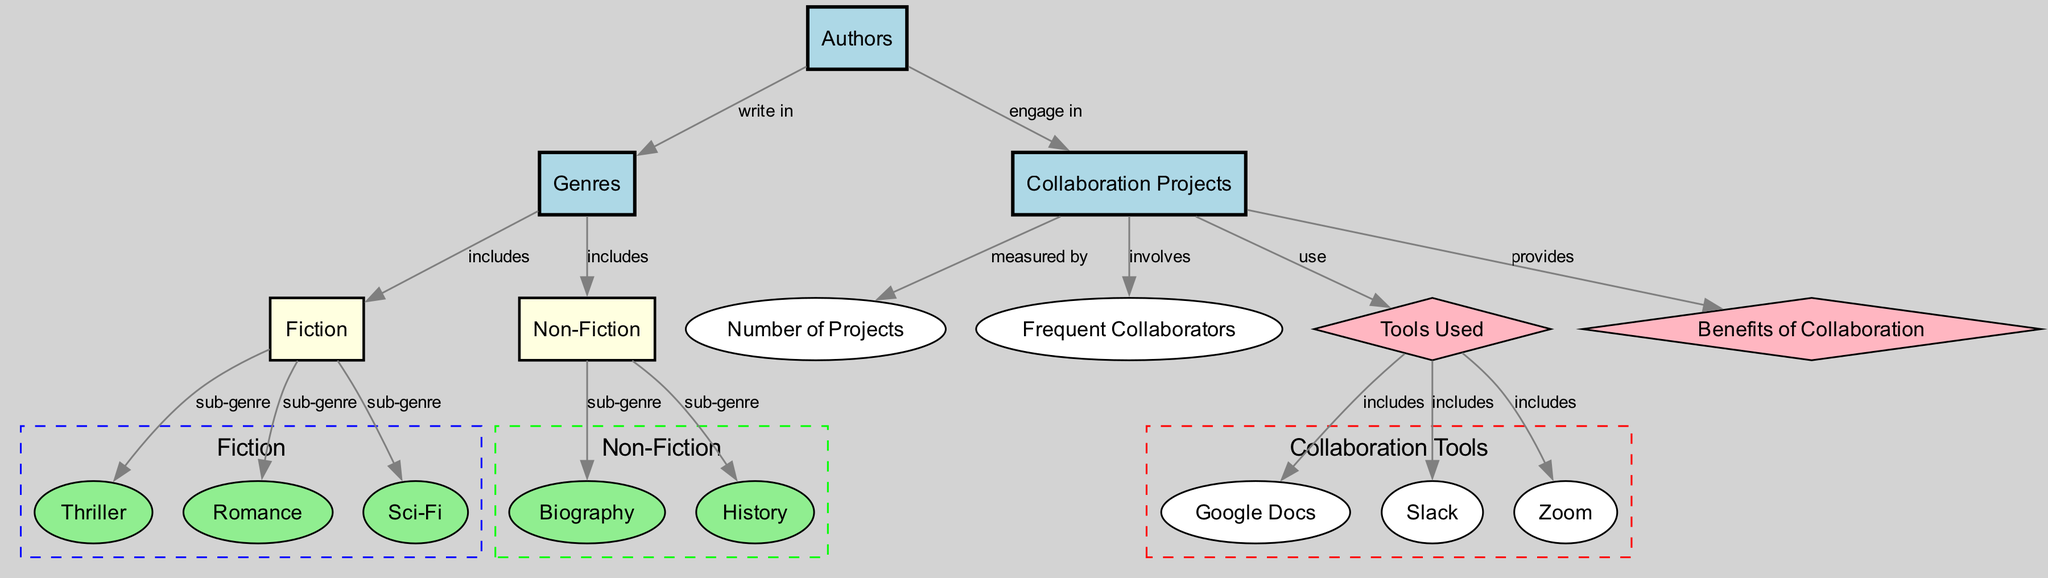What are the main genres depicted in the diagram? The diagram includes two main genres: Fiction and Non-Fiction. These are represented as nodes that connect to their respective sub-genres.
Answer: Fiction, Non-Fiction How many frequent collaborators are mentioned in collaboration projects? The diagram categorizes collaboration projects but does not specify a numerical value directly under frequent collaborators. It's a node that can involve multiple authors but doesn't provide a specific number.
Answer: Not specified Which tool is categorized under tools used for collaboration? Three tools are listed as part of the collaboration tools: Google Docs, Slack, and Zoom. Each is connected to the tools used node.
Answer: Google Docs, Slack, Zoom What type of relationship is there between authors and collaboration projects? The relationship is described as "engage in," indicating that the authors actively participate in or are involved in collaboration projects.
Answer: Engage in How many sub-genres are associated with Fiction? Within the Fiction genre, there are three sub-genres categorized: Thriller, Romance, and Sci-Fi. These are represented as direct connections from the Fiction node.
Answer: 3 What genre does Biography belong to? Biography is a sub-genre that belongs to the Non-Fiction genre. The diagram shows a directed edge from Non-Fiction to Biography.
Answer: Non-Fiction What is one benefit of collaboration depicted in the diagram? The diagram outlines that collaboration projects provide benefits. However, specific benefits are not detailed as nodes or edges in the diagram.
Answer: Not specified Which collaboration tool is not visually represented in the diagram? The only tools mentioned in the diagram are Google Docs, Slack, and Zoom. Since no other tool is indicated, any other tool not listed does not appear in the visual representation.
Answer: Not specified What genre includes History as a sub-genre? History is categorized under the Non-Fiction genre as one of its sub-genres. The relationship is clearly described by an edge connecting Non-Fiction to History.
Answer: Non-Fiction 